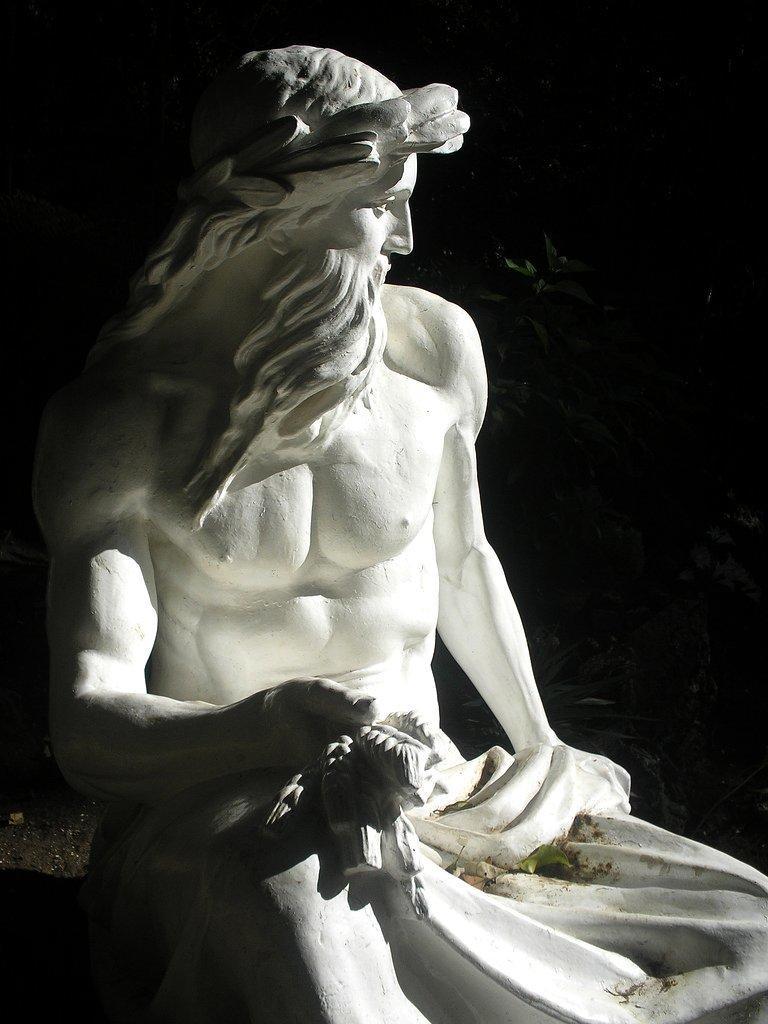Describe this image in one or two sentences. Background portion of the picture is completely dark. In this picture we can see the statue of a man. 